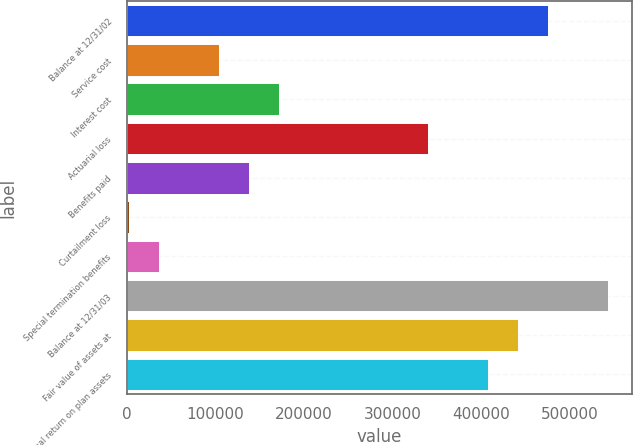Convert chart to OTSL. <chart><loc_0><loc_0><loc_500><loc_500><bar_chart><fcel>Balance at 12/31/02<fcel>Service cost<fcel>Interest cost<fcel>Actuarial loss<fcel>Benefits paid<fcel>Curtailment loss<fcel>Special termination benefits<fcel>Balance at 12/31/03<fcel>Fair value of assets at<fcel>Actual return on plan assets<nl><fcel>475281<fcel>103842<fcel>171376<fcel>340212<fcel>137609<fcel>2540<fcel>36307.2<fcel>542815<fcel>441514<fcel>407746<nl></chart> 